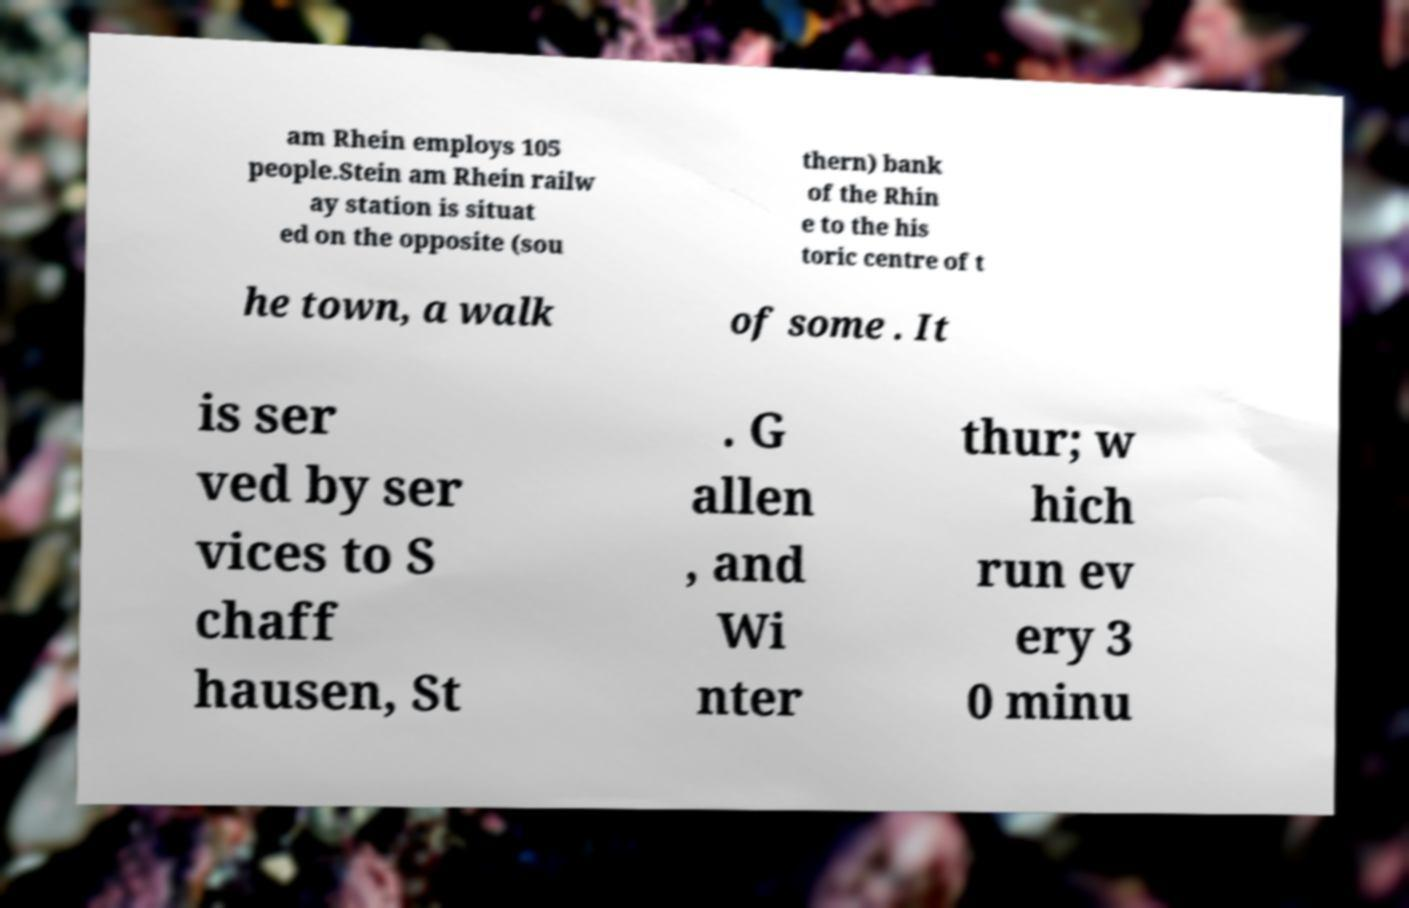Can you accurately transcribe the text from the provided image for me? am Rhein employs 105 people.Stein am Rhein railw ay station is situat ed on the opposite (sou thern) bank of the Rhin e to the his toric centre of t he town, a walk of some . It is ser ved by ser vices to S chaff hausen, St . G allen , and Wi nter thur; w hich run ev ery 3 0 minu 